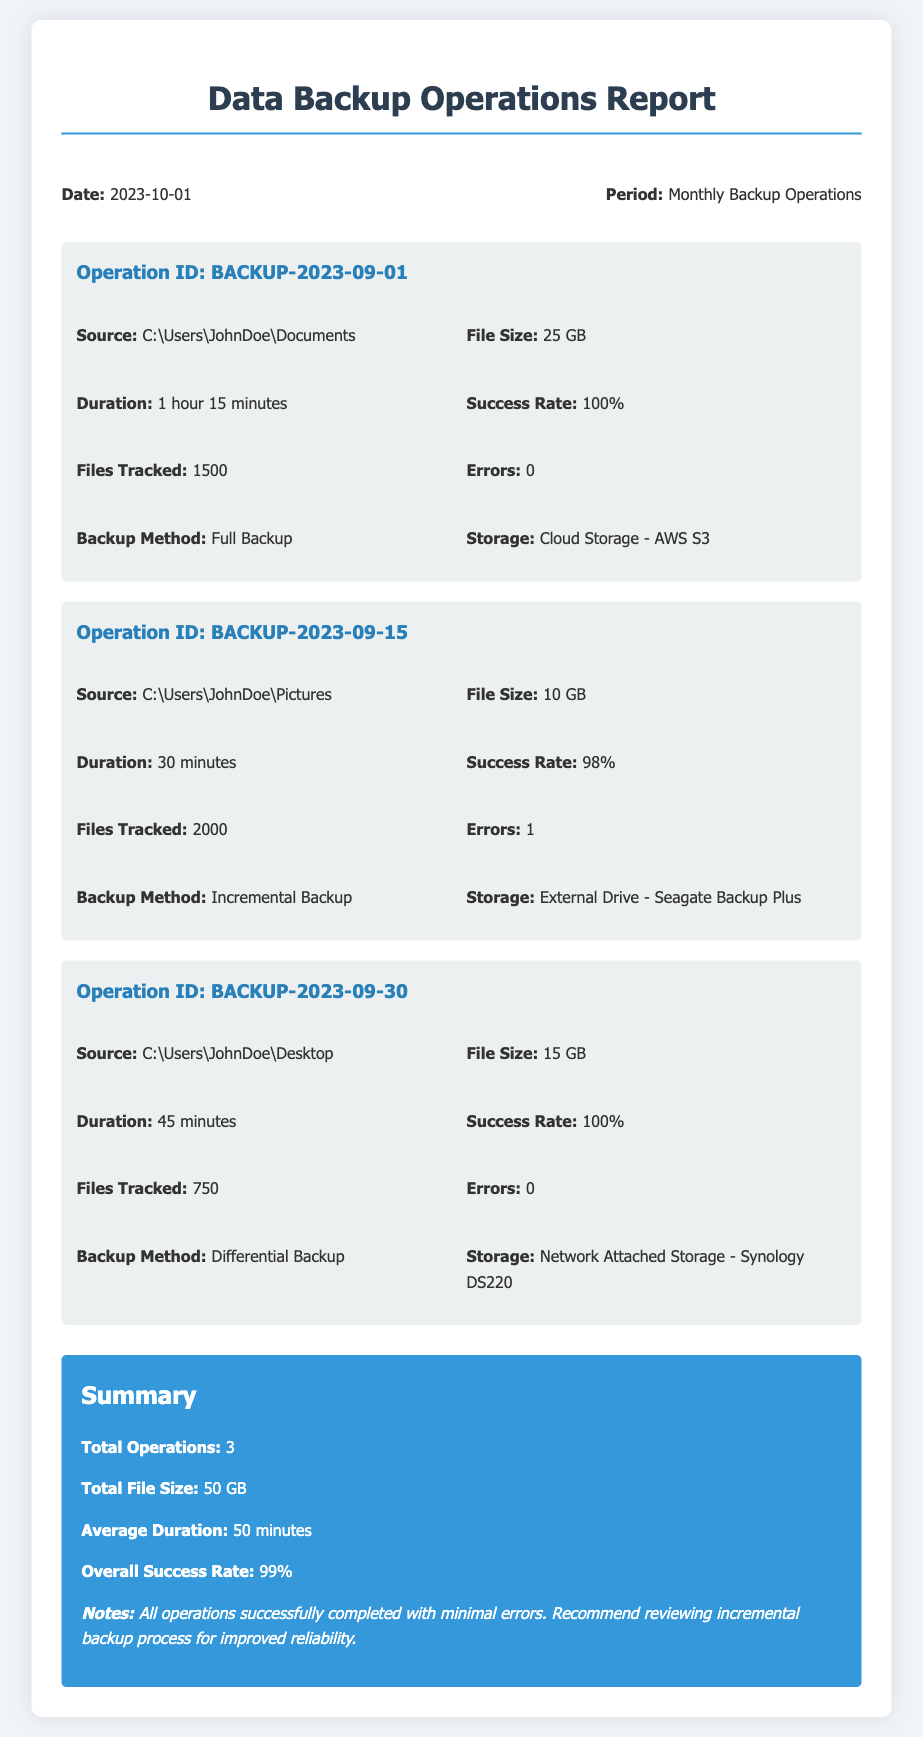what is the date of the report? The report is dated 2023-10-01.
Answer: 2023-10-01 how many operations were performed? The total number of operations is summarized in the document, which states there are 3 operations.
Answer: 3 what is the file size of the first backup operation? The first backup operation (BACKUP-2023-09-01) has a file size of 25 GB.
Answer: 25 GB what is the success rate of the second operation? The document states that the success rate for the second operation (BACKUP-2023-09-15) is 98%.
Answer: 98% what storage was used for the third operation? The third operation used Network Attached Storage - Synology DS220 for storage.
Answer: Network Attached Storage - Synology DS220 what is the total file size for all operations combined? The total file size is the sum of individual operations, which is 50 GB as noted in the summary.
Answer: 50 GB what are the errors recorded in the second backup operation? The second operation (BACKUP-2023-09-15) recorded 1 error.
Answer: 1 what was the average duration of the backup operations? The average duration is provided in the summary, which is 50 minutes.
Answer: 50 minutes what does the notes section recommend? The notes suggest reviewing the incremental backup process for improved reliability.
Answer: reviewing incremental backup process 